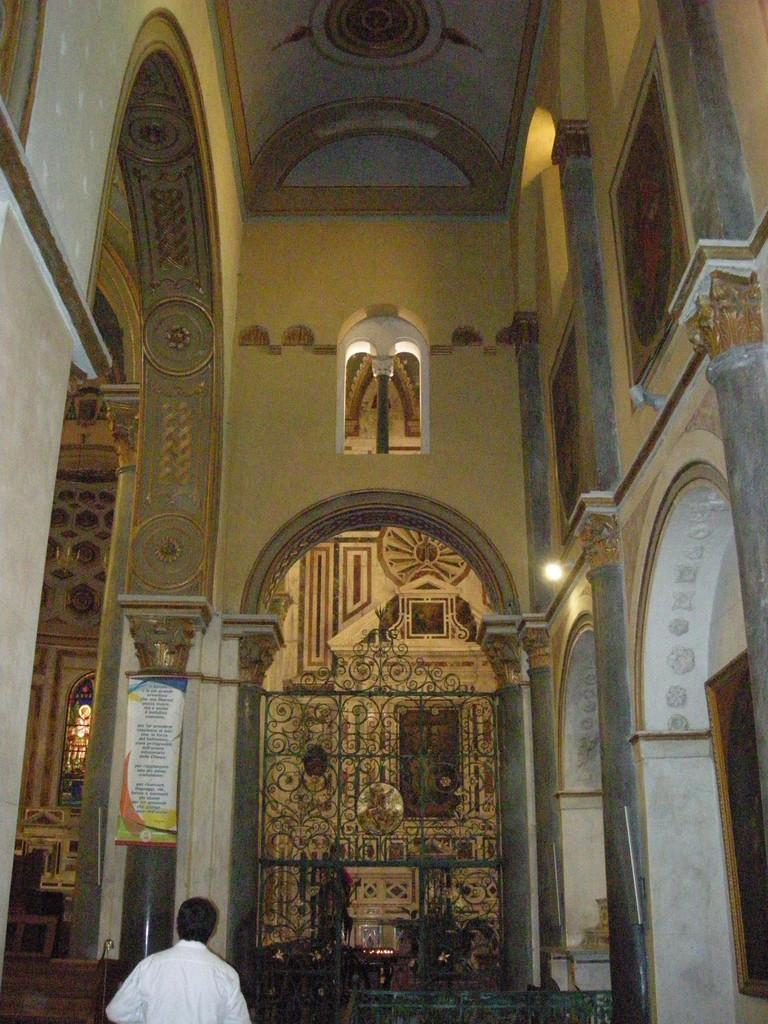What type of location is depicted in the image? The image is of the inside of a building. What architectural features can be seen in the image? There are pillars and walls in the image. Are there any decorative elements in the image? Yes, there are carvings in the image. Can you describe the person visible in the image? A person is visible at the bottom of the image. What objects are present at the bottom of the image? There are objects at the bottom of the image. What other elements can be seen in the image? There is a grille, a banner, and a photo frame in the image. What type of meal is being prepared in the image? There is no meal being prepared in the image; it depicts the inside of a building with various architectural and decorative elements. Can you describe the print on the banner in the image? There is no print on the banner in the image; it is a solid color. 